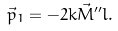<formula> <loc_0><loc_0><loc_500><loc_500>\vec { p } _ { 1 } = - 2 k \vec { M } ^ { \prime \prime } l .</formula> 